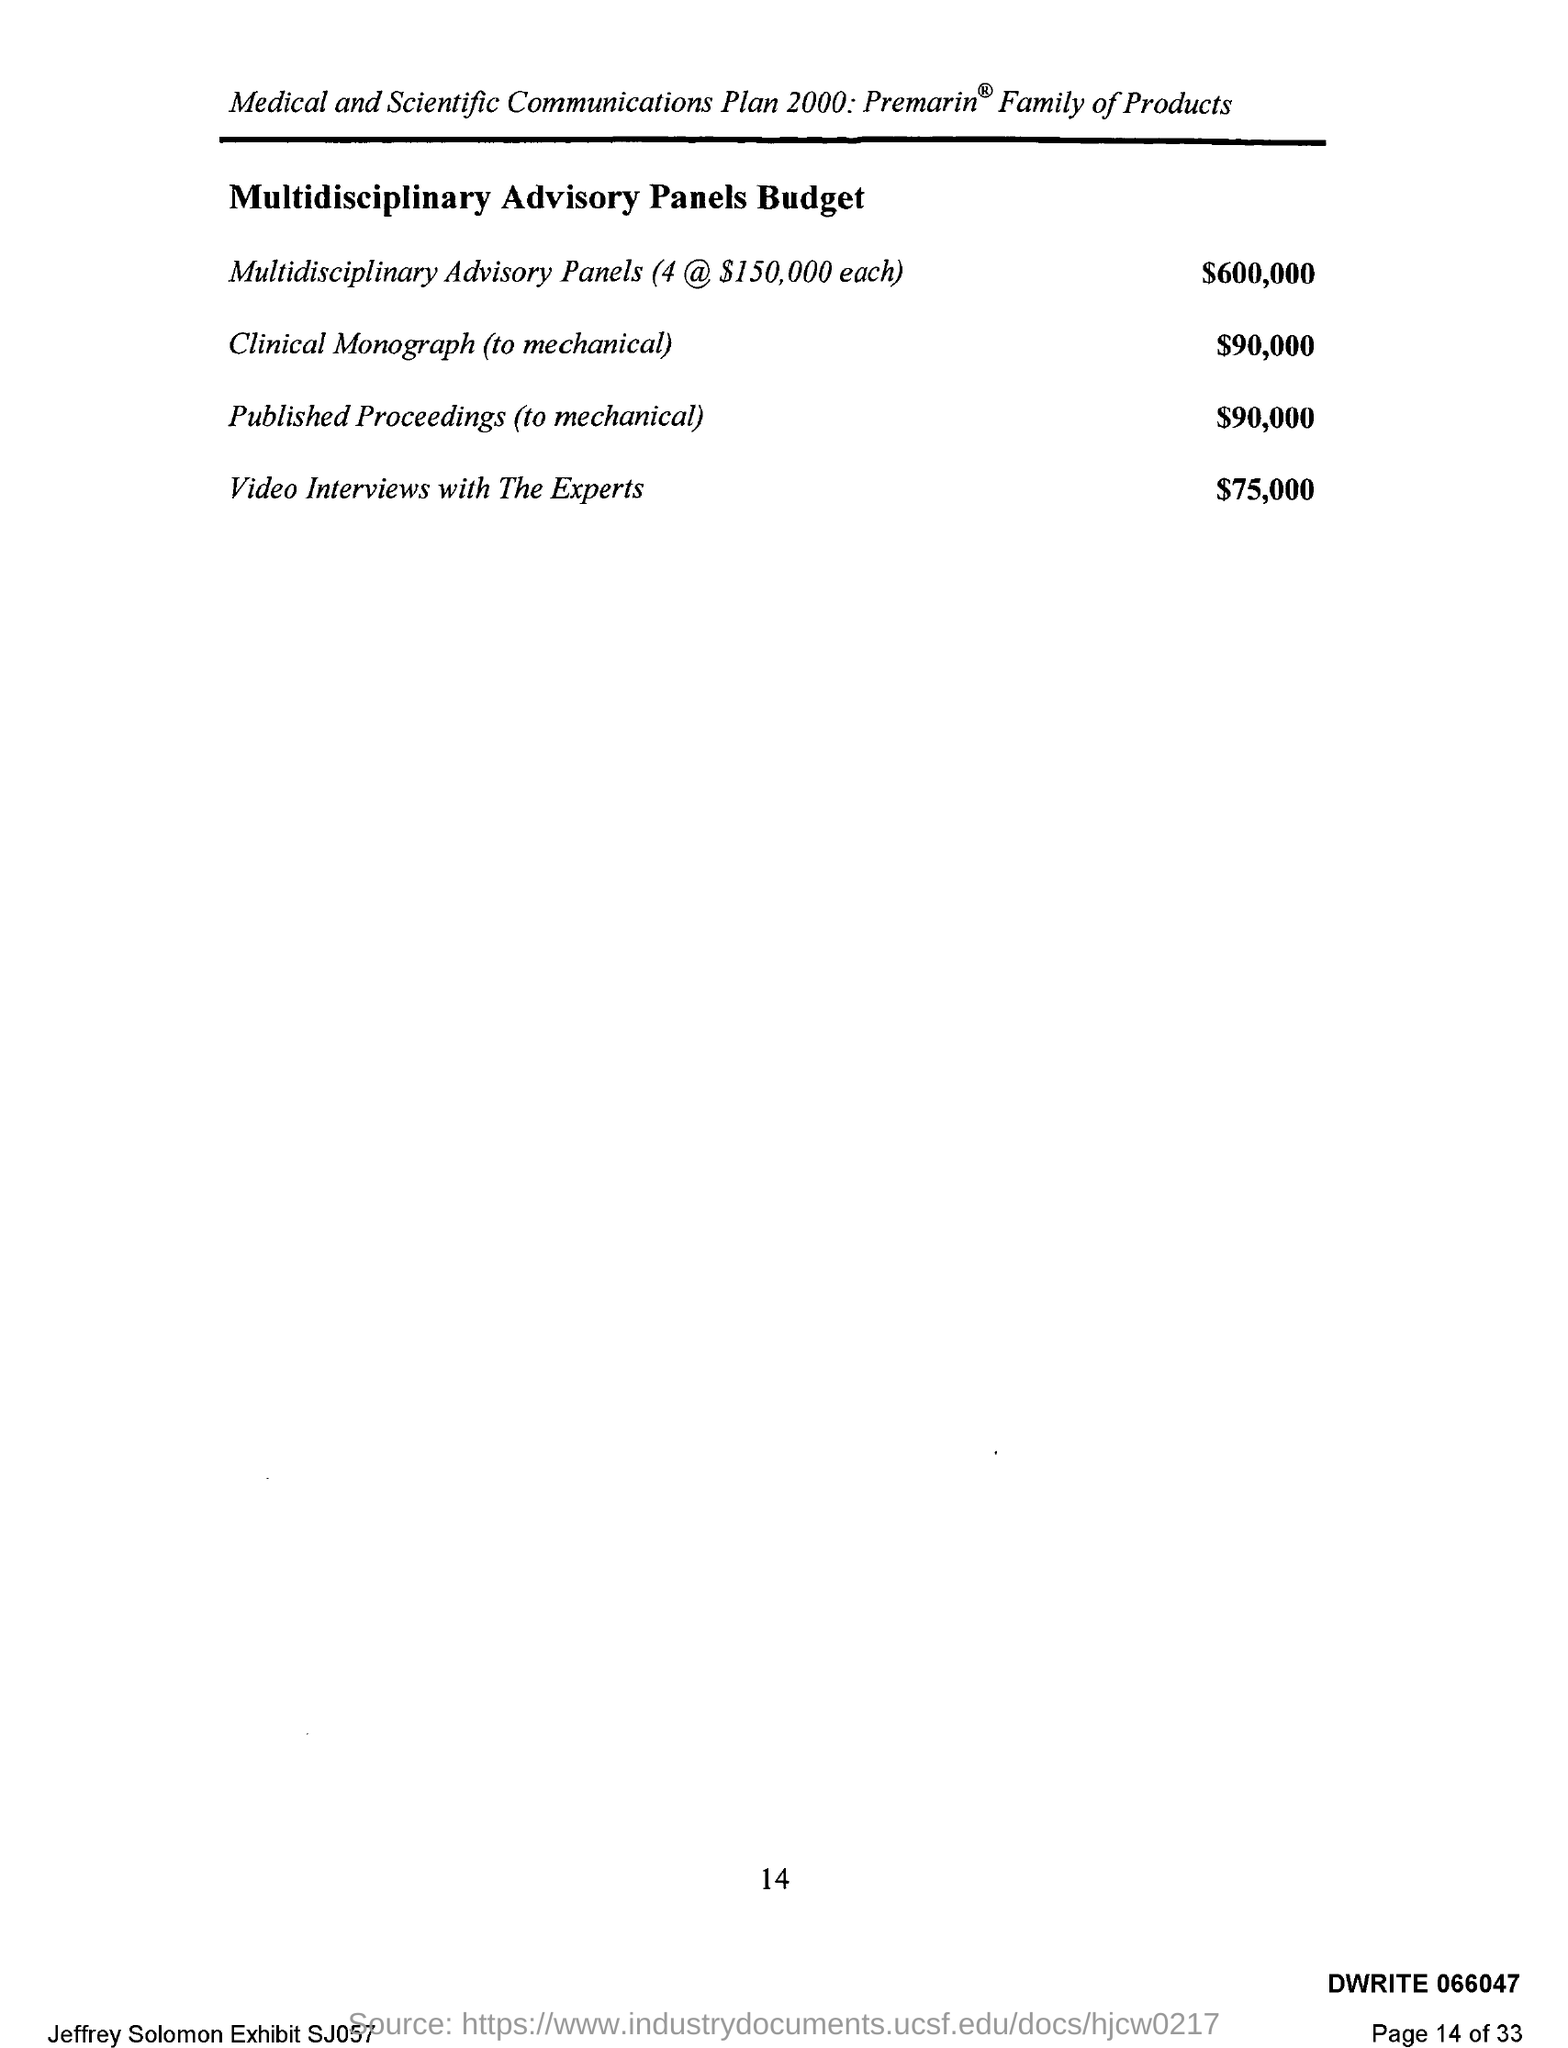What is the multidisciplinary advisory panels budget for clinical monograph(to mechanical )?
Give a very brief answer. $90,000. What is the multidisciplinary advisory panels budget for published proceedings (to mechanical )?
Your answer should be very brief. $90,000. What is the advisory panels budget for video interviews with the experts ?
Your answer should be very brief. $ 75,000. What is the name of the plan mentioned ?
Ensure brevity in your answer.  Medical and Scientific Communications plan 2000. 